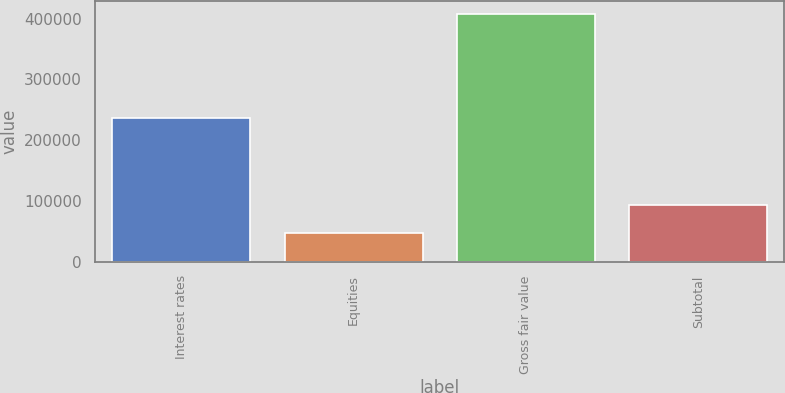Convert chart to OTSL. <chart><loc_0><loc_0><loc_500><loc_500><bar_chart><fcel>Interest rates<fcel>Equities<fcel>Gross fair value<fcel>Subtotal<nl><fcel>236100<fcel>48118<fcel>407796<fcel>94229<nl></chart> 